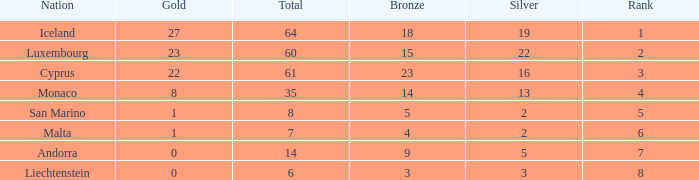How many bronzes for nations with over 22 golds and ranked under 2? 18.0. 